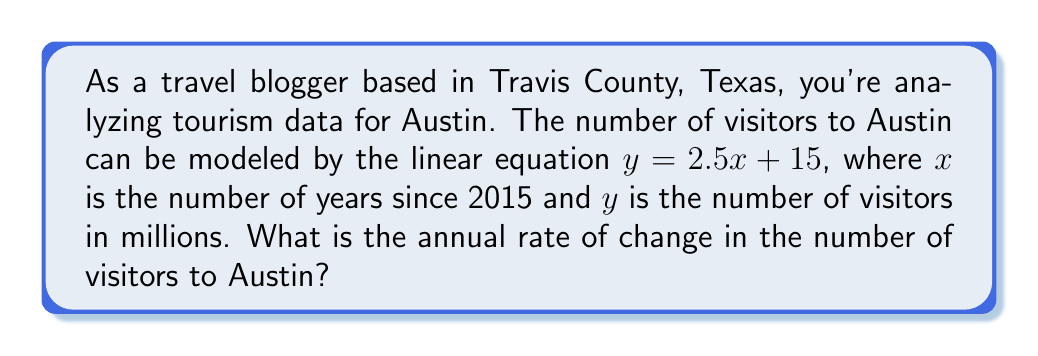What is the answer to this math problem? To determine the rate of change in tourism statistics using a linear equation, we need to focus on the slope of the line. The general form of a linear equation is:

$y = mx + b$

Where:
- $m$ is the slope (rate of change)
- $b$ is the y-intercept

In our given equation:
$y = 2.5x + 15$

We can identify that:
- $m = 2.5$
- $b = 15$

The slope $m$ represents the rate of change. In this context, it means that for each increase of 1 in the $x$ value (which represents one year), the $y$ value (number of visitors in millions) increases by 2.5.

Therefore, the annual rate of change in the number of visitors to Austin is 2.5 million visitors per year.
Answer: 2.5 million visitors/year 